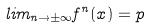<formula> <loc_0><loc_0><loc_500><loc_500>l i m _ { n \rightarrow \pm \infty } f ^ { n } ( x ) = p</formula> 